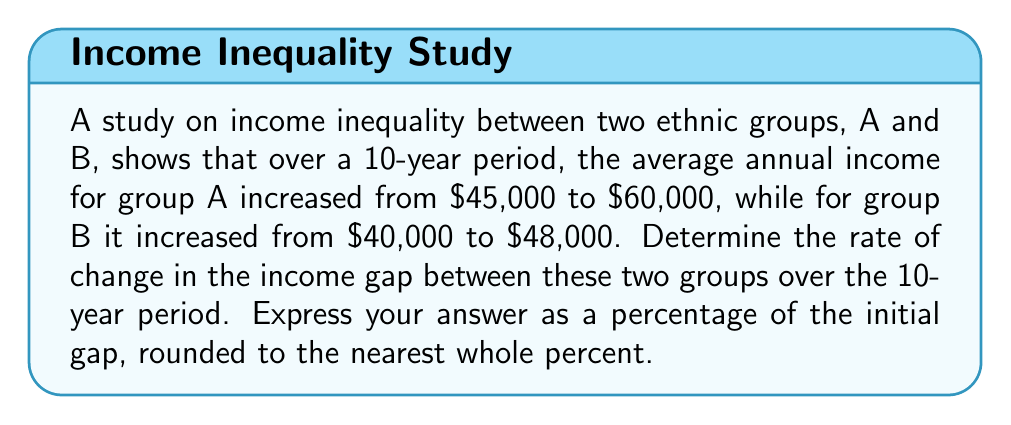Show me your answer to this math problem. To solve this problem, we need to follow these steps:

1. Calculate the initial income gap:
   Initial gap = $45,000 - $40,000 = $5,000

2. Calculate the final income gap:
   Final gap = $60,000 - $48,000 = $12,000

3. Calculate the change in the income gap:
   Change in gap = Final gap - Initial gap
   $\Delta$ gap = $12,000 - $5,000 = $7,000

4. Calculate the rate of change relative to the initial gap:
   Rate of change = $\frac{\text{Change in gap}}{\text{Initial gap}} \times 100\%$

   $$\text{Rate of change} = \frac{7000}{5000} \times 100\% = 1.4 \times 100\% = 140\%$$

5. Round to the nearest whole percent:
   140% (no rounding needed)

This result indicates that the income gap between the two ethnic groups increased by 140% over the 10-year period, highlighting a significant growth in income inequality.
Answer: 140% 